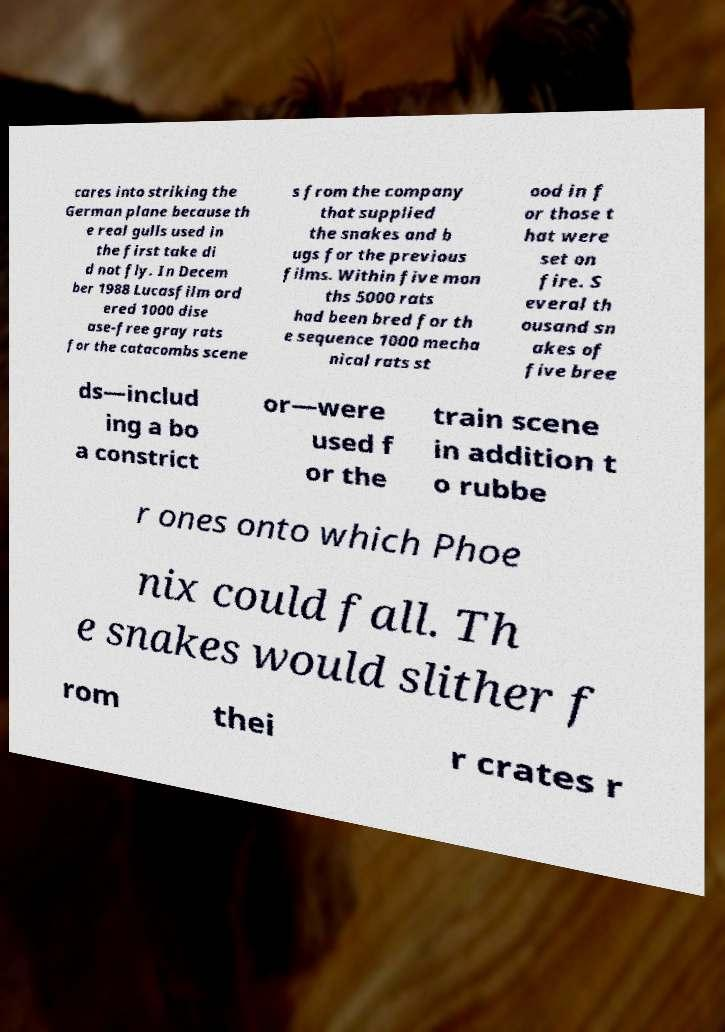Could you extract and type out the text from this image? cares into striking the German plane because th e real gulls used in the first take di d not fly. In Decem ber 1988 Lucasfilm ord ered 1000 dise ase-free gray rats for the catacombs scene s from the company that supplied the snakes and b ugs for the previous films. Within five mon ths 5000 rats had been bred for th e sequence 1000 mecha nical rats st ood in f or those t hat were set on fire. S everal th ousand sn akes of five bree ds—includ ing a bo a constrict or—were used f or the train scene in addition t o rubbe r ones onto which Phoe nix could fall. Th e snakes would slither f rom thei r crates r 